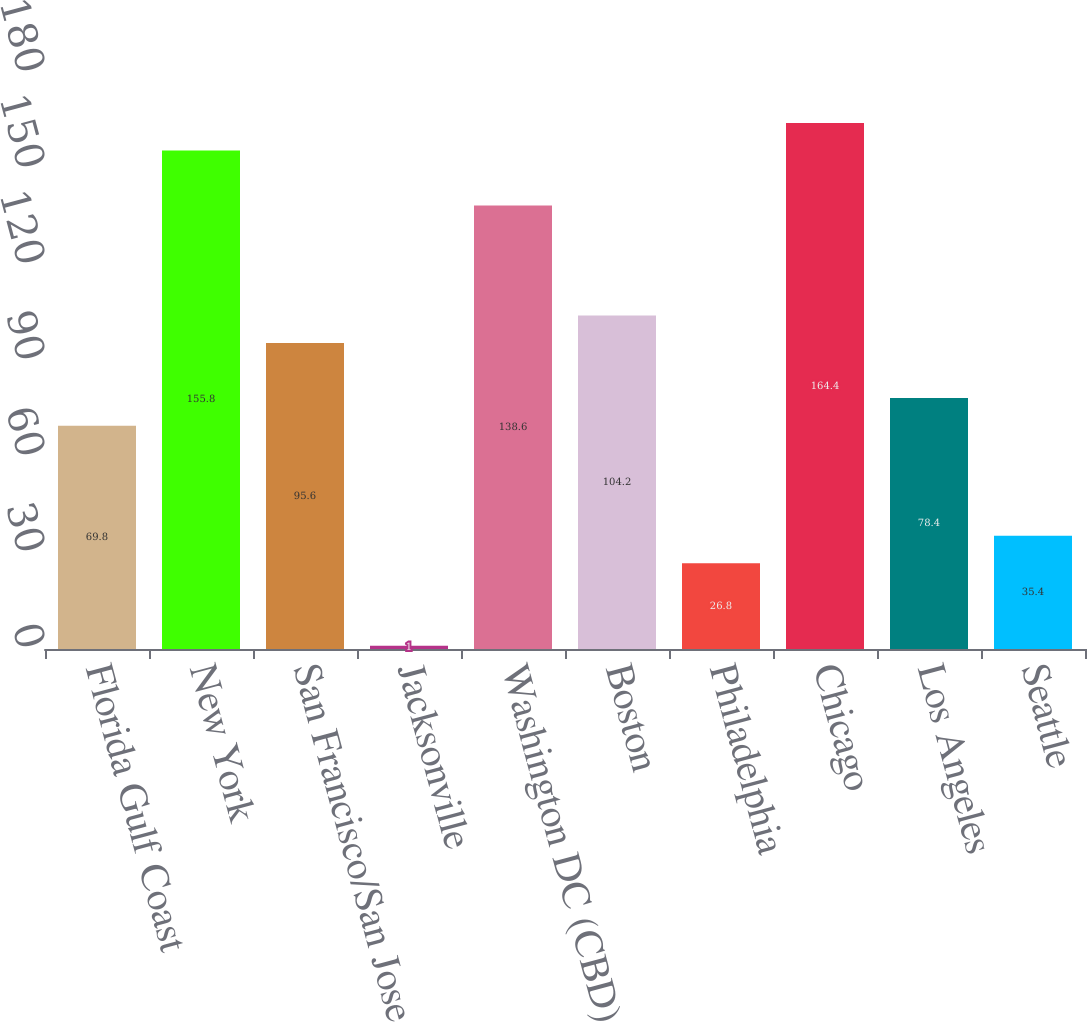<chart> <loc_0><loc_0><loc_500><loc_500><bar_chart><fcel>Florida Gulf Coast<fcel>New York<fcel>San Francisco/San Jose<fcel>Jacksonville<fcel>Washington DC (CBD)<fcel>Boston<fcel>Philadelphia<fcel>Chicago<fcel>Los Angeles<fcel>Seattle<nl><fcel>69.8<fcel>155.8<fcel>95.6<fcel>1<fcel>138.6<fcel>104.2<fcel>26.8<fcel>164.4<fcel>78.4<fcel>35.4<nl></chart> 